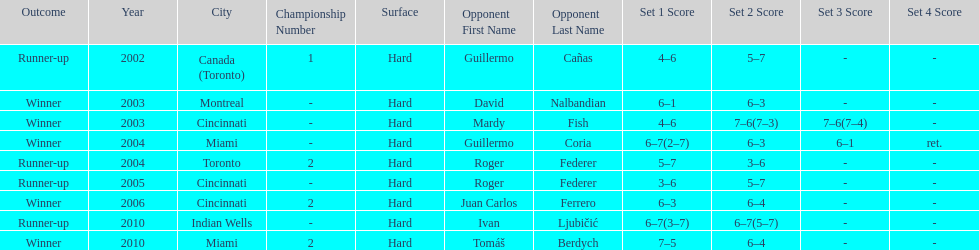How many times has he been runner-up? 4. 